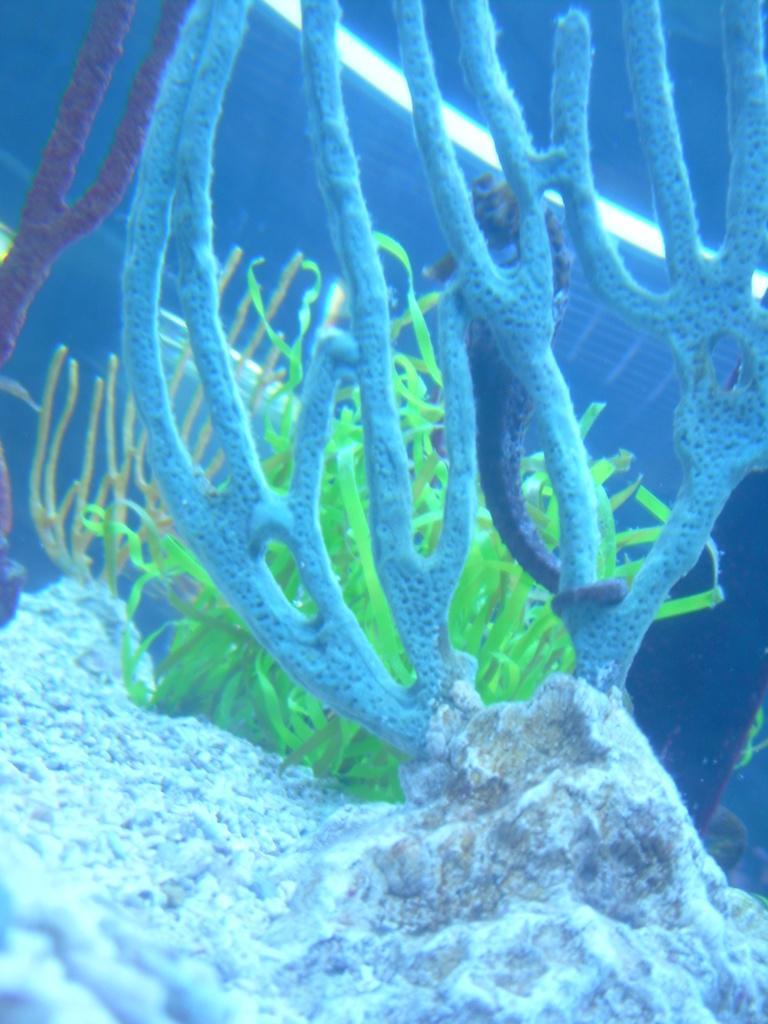Could you give a brief overview of what you see in this image? In this image I can see an aquatic plants and stone. They are in white,blue and green color. 